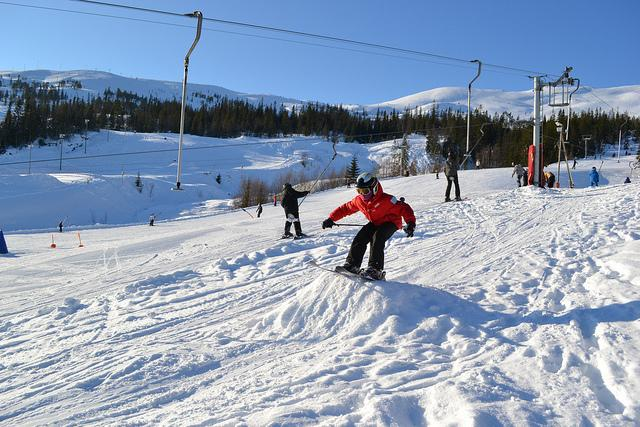After traversing over the jump what natural force will cause the boarder to return to the ground? gravity 